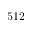<formula> <loc_0><loc_0><loc_500><loc_500>5 1 2</formula> 